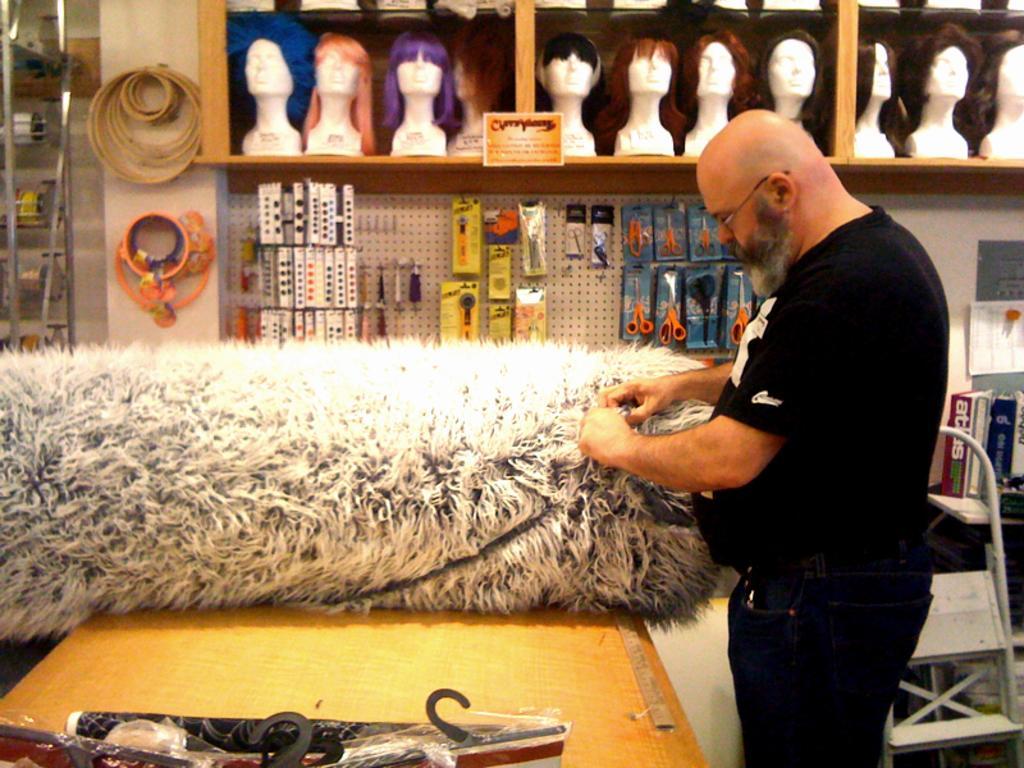Describe this image in one or two sentences. In the center of the image there is a table on which there is a wool object. To the right side of the image there is a person wearing a black color t-shirt. In the background of the image there is a shelf In which there are wigs and other objects. 